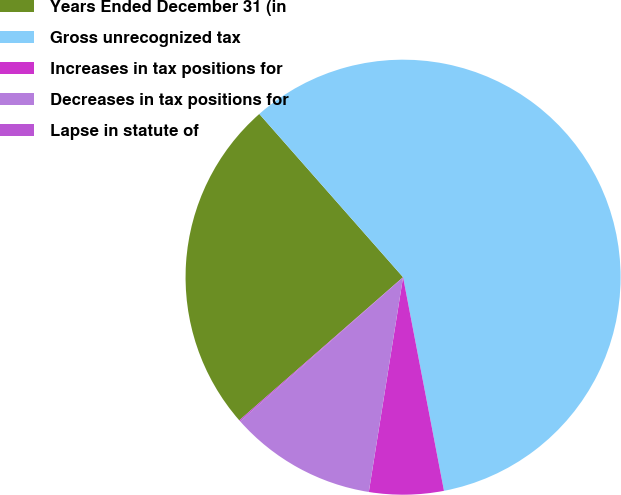Convert chart to OTSL. <chart><loc_0><loc_0><loc_500><loc_500><pie_chart><fcel>Years Ended December 31 (in<fcel>Gross unrecognized tax<fcel>Increases in tax positions for<fcel>Decreases in tax positions for<fcel>Lapse in statute of<nl><fcel>24.94%<fcel>58.48%<fcel>5.53%<fcel>10.95%<fcel>0.1%<nl></chart> 